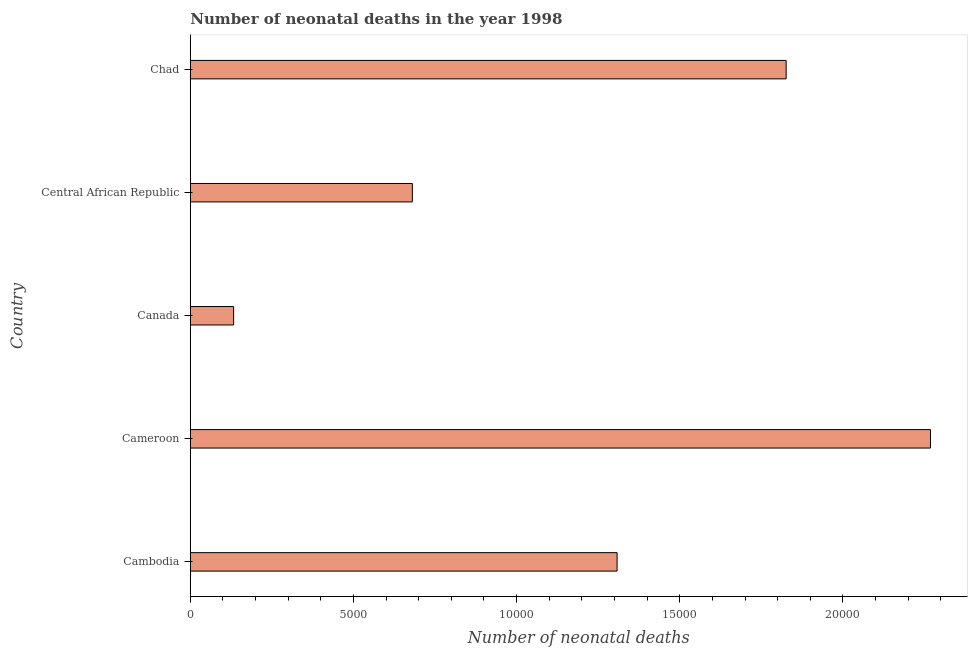What is the title of the graph?
Your answer should be very brief. Number of neonatal deaths in the year 1998. What is the label or title of the X-axis?
Provide a short and direct response. Number of neonatal deaths. What is the label or title of the Y-axis?
Ensure brevity in your answer.  Country. What is the number of neonatal deaths in Cameroon?
Ensure brevity in your answer.  2.27e+04. Across all countries, what is the maximum number of neonatal deaths?
Offer a terse response. 2.27e+04. Across all countries, what is the minimum number of neonatal deaths?
Offer a very short reply. 1328. In which country was the number of neonatal deaths maximum?
Provide a short and direct response. Cameroon. What is the sum of the number of neonatal deaths?
Give a very brief answer. 6.22e+04. What is the difference between the number of neonatal deaths in Central African Republic and Chad?
Your answer should be compact. -1.15e+04. What is the average number of neonatal deaths per country?
Your answer should be very brief. 1.24e+04. What is the median number of neonatal deaths?
Make the answer very short. 1.31e+04. What is the ratio of the number of neonatal deaths in Canada to that in Central African Republic?
Ensure brevity in your answer.  0.2. Is the number of neonatal deaths in Canada less than that in Chad?
Provide a short and direct response. Yes. Is the difference between the number of neonatal deaths in Cameroon and Central African Republic greater than the difference between any two countries?
Provide a short and direct response. No. What is the difference between the highest and the second highest number of neonatal deaths?
Give a very brief answer. 4423. What is the difference between the highest and the lowest number of neonatal deaths?
Give a very brief answer. 2.14e+04. In how many countries, is the number of neonatal deaths greater than the average number of neonatal deaths taken over all countries?
Offer a terse response. 3. How many bars are there?
Your answer should be compact. 5. Are all the bars in the graph horizontal?
Keep it short and to the point. Yes. What is the difference between two consecutive major ticks on the X-axis?
Keep it short and to the point. 5000. What is the Number of neonatal deaths of Cambodia?
Offer a very short reply. 1.31e+04. What is the Number of neonatal deaths of Cameroon?
Ensure brevity in your answer.  2.27e+04. What is the Number of neonatal deaths of Canada?
Your answer should be compact. 1328. What is the Number of neonatal deaths in Central African Republic?
Provide a succinct answer. 6805. What is the Number of neonatal deaths in Chad?
Offer a terse response. 1.83e+04. What is the difference between the Number of neonatal deaths in Cambodia and Cameroon?
Your answer should be very brief. -9604. What is the difference between the Number of neonatal deaths in Cambodia and Canada?
Give a very brief answer. 1.18e+04. What is the difference between the Number of neonatal deaths in Cambodia and Central African Republic?
Provide a succinct answer. 6274. What is the difference between the Number of neonatal deaths in Cambodia and Chad?
Your answer should be compact. -5181. What is the difference between the Number of neonatal deaths in Cameroon and Canada?
Ensure brevity in your answer.  2.14e+04. What is the difference between the Number of neonatal deaths in Cameroon and Central African Republic?
Make the answer very short. 1.59e+04. What is the difference between the Number of neonatal deaths in Cameroon and Chad?
Your answer should be very brief. 4423. What is the difference between the Number of neonatal deaths in Canada and Central African Republic?
Make the answer very short. -5477. What is the difference between the Number of neonatal deaths in Canada and Chad?
Your answer should be compact. -1.69e+04. What is the difference between the Number of neonatal deaths in Central African Republic and Chad?
Provide a short and direct response. -1.15e+04. What is the ratio of the Number of neonatal deaths in Cambodia to that in Cameroon?
Make the answer very short. 0.58. What is the ratio of the Number of neonatal deaths in Cambodia to that in Canada?
Give a very brief answer. 9.85. What is the ratio of the Number of neonatal deaths in Cambodia to that in Central African Republic?
Offer a very short reply. 1.92. What is the ratio of the Number of neonatal deaths in Cambodia to that in Chad?
Provide a succinct answer. 0.72. What is the ratio of the Number of neonatal deaths in Cameroon to that in Canada?
Ensure brevity in your answer.  17.08. What is the ratio of the Number of neonatal deaths in Cameroon to that in Central African Republic?
Your answer should be compact. 3.33. What is the ratio of the Number of neonatal deaths in Cameroon to that in Chad?
Give a very brief answer. 1.24. What is the ratio of the Number of neonatal deaths in Canada to that in Central African Republic?
Offer a very short reply. 0.2. What is the ratio of the Number of neonatal deaths in Canada to that in Chad?
Offer a terse response. 0.07. What is the ratio of the Number of neonatal deaths in Central African Republic to that in Chad?
Your response must be concise. 0.37. 